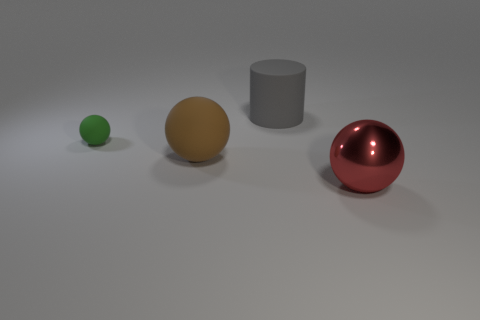There is a sphere that is left of the big rubber thing that is on the left side of the big gray matte cylinder; how big is it?
Offer a terse response. Small. Is the color of the matte cylinder the same as the large thing that is on the right side of the large matte cylinder?
Your answer should be very brief. No. Is the number of small matte balls to the right of the large gray thing less than the number of tiny gray shiny balls?
Provide a short and direct response. No. What number of other things are there of the same size as the green thing?
Make the answer very short. 0. Is the shape of the big rubber object that is in front of the large cylinder the same as  the large gray matte object?
Your response must be concise. No. Is the number of things behind the brown matte ball greater than the number of large rubber balls?
Give a very brief answer. Yes. There is a thing that is both to the right of the tiny rubber object and behind the big brown object; what is its material?
Provide a succinct answer. Rubber. Are there any other things that have the same shape as the brown rubber thing?
Offer a terse response. Yes. How many objects are both behind the small matte sphere and right of the big gray object?
Give a very brief answer. 0. What is the material of the brown thing?
Offer a terse response. Rubber. 